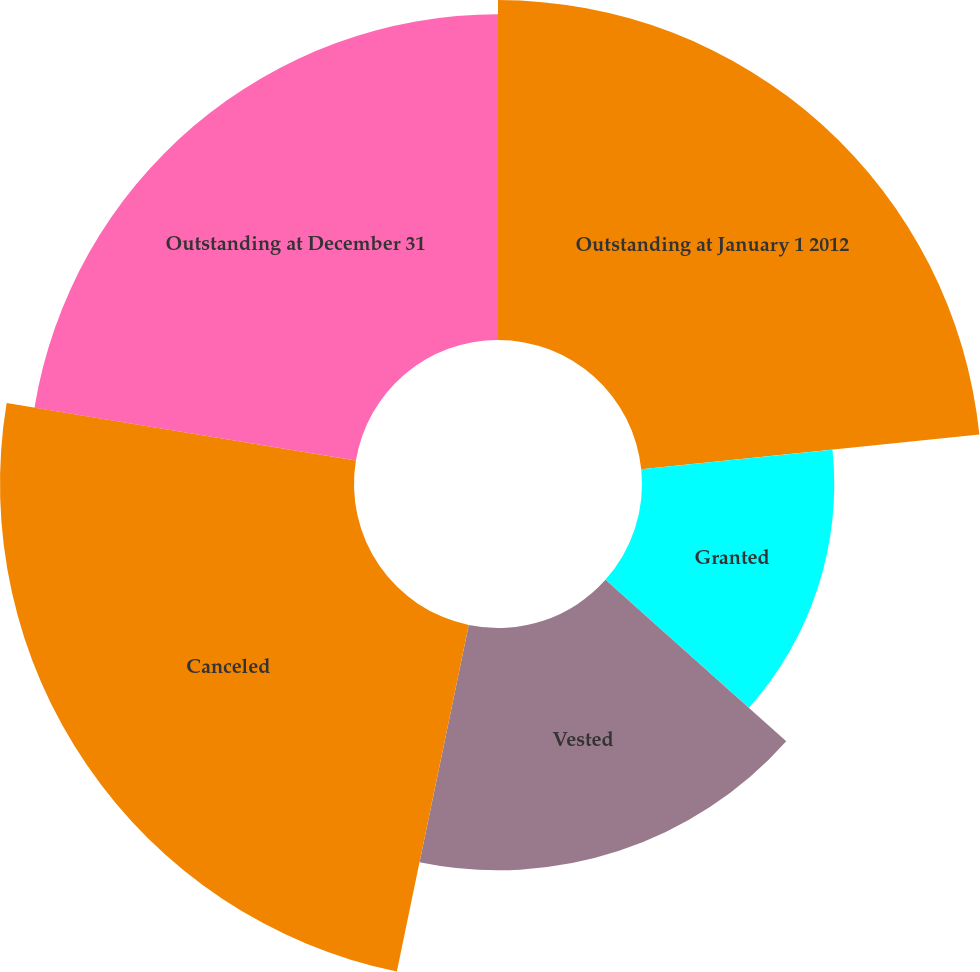<chart> <loc_0><loc_0><loc_500><loc_500><pie_chart><fcel>Outstanding at January 1 2012<fcel>Granted<fcel>Vested<fcel>Canceled<fcel>Outstanding at December 31<nl><fcel>23.37%<fcel>13.22%<fcel>16.66%<fcel>24.34%<fcel>22.4%<nl></chart> 